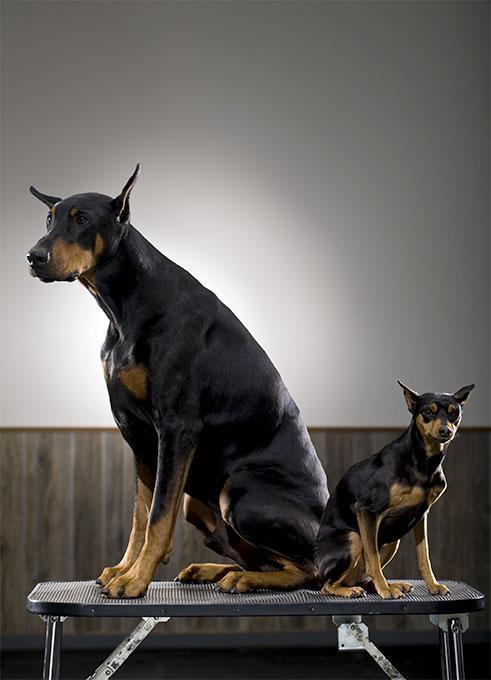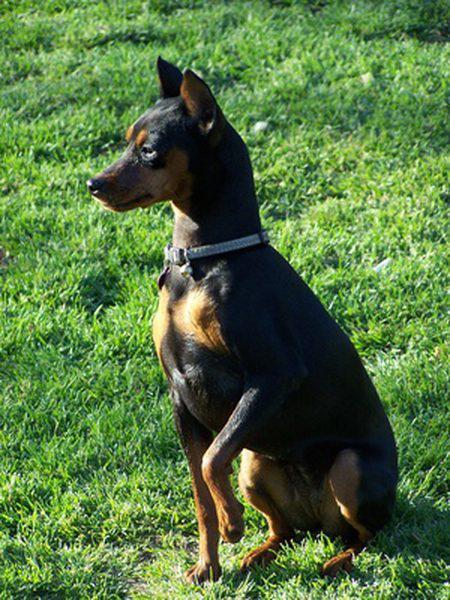The first image is the image on the left, the second image is the image on the right. Considering the images on both sides, is "The left image contains at least two dogs." valid? Answer yes or no. Yes. The first image is the image on the left, the second image is the image on the right. For the images shown, is this caption "tere is a dog sitting in the grass wearing a color and has pointy ears" true? Answer yes or no. Yes. 